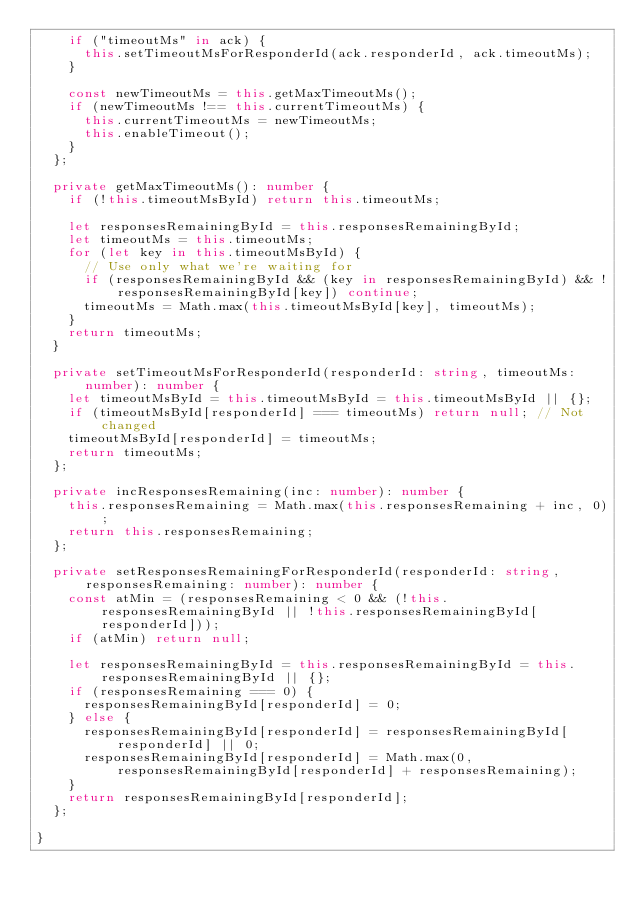Convert code to text. <code><loc_0><loc_0><loc_500><loc_500><_TypeScript_>    if ("timeoutMs" in ack) {
      this.setTimeoutMsForResponderId(ack.responderId, ack.timeoutMs);
    }

    const newTimeoutMs = this.getMaxTimeoutMs();
    if (newTimeoutMs !== this.currentTimeoutMs) {
      this.currentTimeoutMs = newTimeoutMs;
      this.enableTimeout();
    }
  };

  private getMaxTimeoutMs(): number {
    if (!this.timeoutMsById) return this.timeoutMs;

    let responsesRemainingById = this.responsesRemainingById;
    let timeoutMs = this.timeoutMs;
    for (let key in this.timeoutMsById) {
      // Use only what we're waiting for
      if (responsesRemainingById && (key in responsesRemainingById) && !responsesRemainingById[key]) continue;
      timeoutMs = Math.max(this.timeoutMsById[key], timeoutMs);
    }
    return timeoutMs;
  }

  private setTimeoutMsForResponderId(responderId: string, timeoutMs: number): number {
    let timeoutMsById = this.timeoutMsById = this.timeoutMsById || {};
    if (timeoutMsById[responderId] === timeoutMs) return null; // Not changed
    timeoutMsById[responderId] = timeoutMs;
    return timeoutMs;
  };

  private incResponsesRemaining(inc: number): number {
    this.responsesRemaining = Math.max(this.responsesRemaining + inc, 0);
    return this.responsesRemaining;
  };

  private setResponsesRemainingForResponderId(responderId: string, responsesRemaining: number): number {
    const atMin = (responsesRemaining < 0 && (!this.responsesRemainingById || !this.responsesRemainingById[responderId]));
    if (atMin) return null;

    let responsesRemainingById = this.responsesRemainingById = this.responsesRemainingById || {};
    if (responsesRemaining === 0) {
      responsesRemainingById[responderId] = 0;
    } else {
      responsesRemainingById[responderId] = responsesRemainingById[responderId] || 0;
      responsesRemainingById[responderId] = Math.max(0, responsesRemainingById[responderId] + responsesRemaining);
    }
    return responsesRemainingById[responderId];
  };

}
</code> 